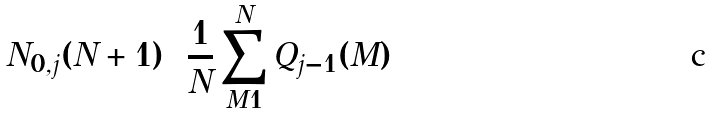<formula> <loc_0><loc_0><loc_500><loc_500>N _ { 0 , j } ( N + 1 ) = \frac { 1 } { N } \sum _ { M = 1 } ^ { N } Q _ { j - 1 } ( M )</formula> 